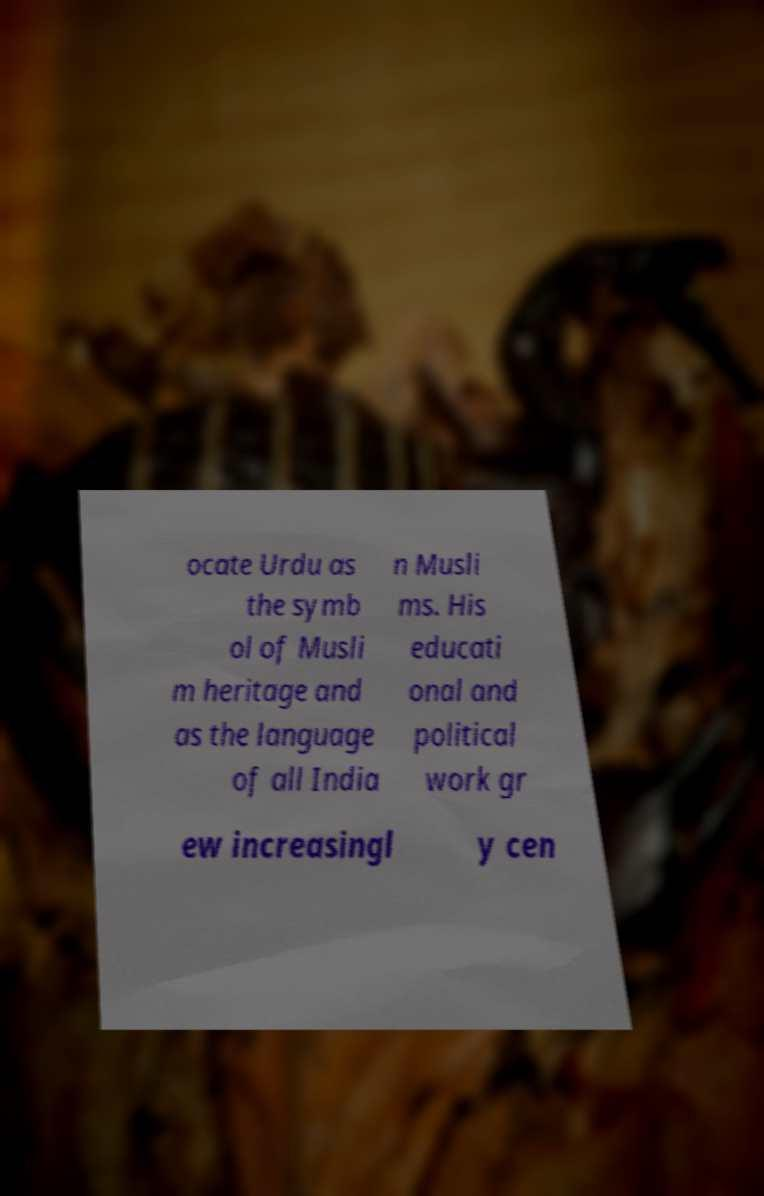Could you assist in decoding the text presented in this image and type it out clearly? ocate Urdu as the symb ol of Musli m heritage and as the language of all India n Musli ms. His educati onal and political work gr ew increasingl y cen 